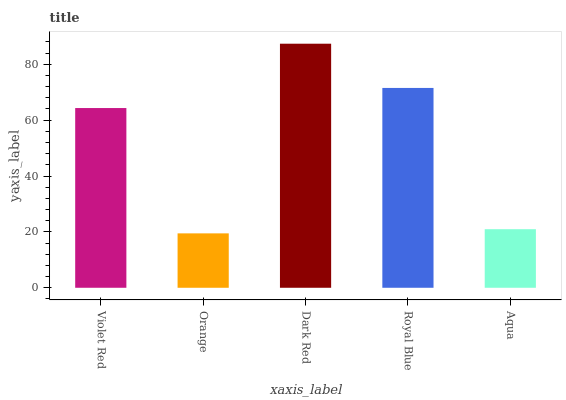Is Orange the minimum?
Answer yes or no. Yes. Is Dark Red the maximum?
Answer yes or no. Yes. Is Dark Red the minimum?
Answer yes or no. No. Is Orange the maximum?
Answer yes or no. No. Is Dark Red greater than Orange?
Answer yes or no. Yes. Is Orange less than Dark Red?
Answer yes or no. Yes. Is Orange greater than Dark Red?
Answer yes or no. No. Is Dark Red less than Orange?
Answer yes or no. No. Is Violet Red the high median?
Answer yes or no. Yes. Is Violet Red the low median?
Answer yes or no. Yes. Is Dark Red the high median?
Answer yes or no. No. Is Dark Red the low median?
Answer yes or no. No. 